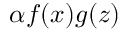Convert formula to latex. <formula><loc_0><loc_0><loc_500><loc_500>\alpha f ( x ) g ( z )</formula> 